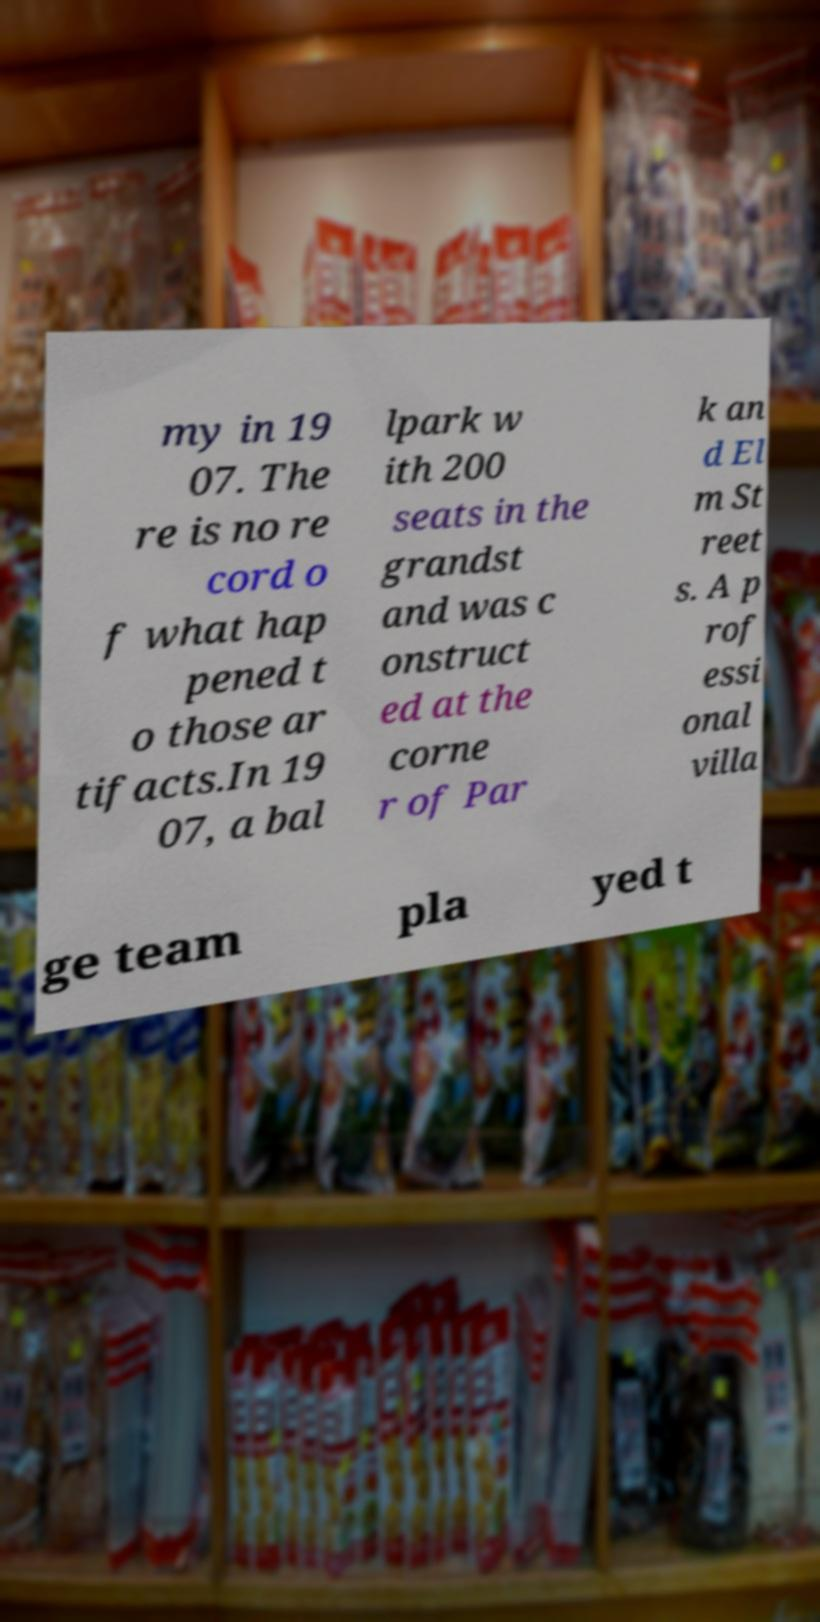Can you accurately transcribe the text from the provided image for me? my in 19 07. The re is no re cord o f what hap pened t o those ar tifacts.In 19 07, a bal lpark w ith 200 seats in the grandst and was c onstruct ed at the corne r of Par k an d El m St reet s. A p rof essi onal villa ge team pla yed t 